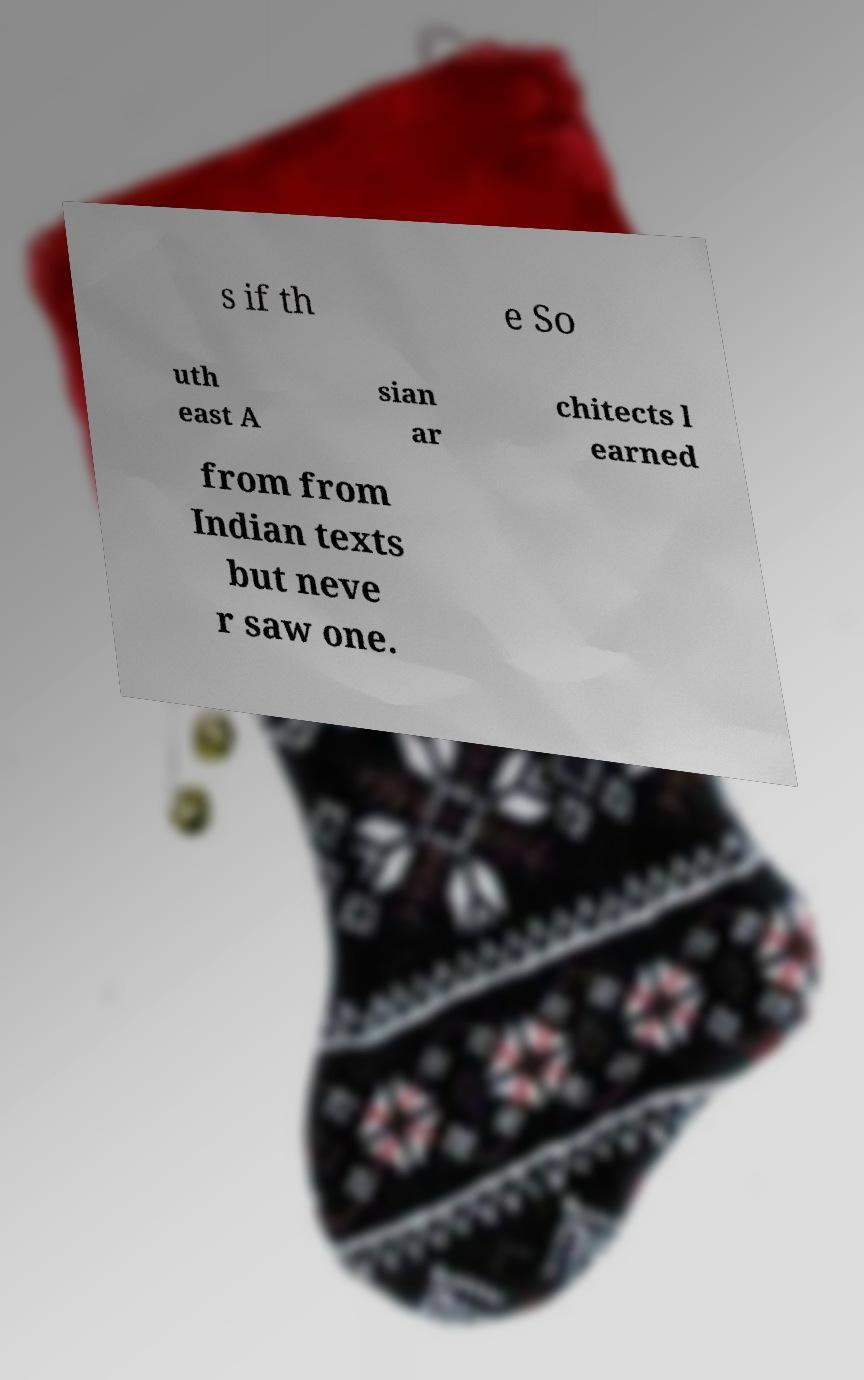What messages or text are displayed in this image? I need them in a readable, typed format. s if th e So uth east A sian ar chitects l earned from from Indian texts but neve r saw one. 